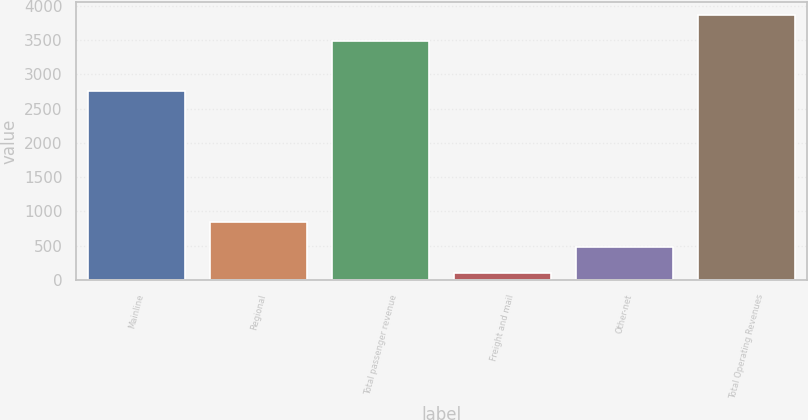Convert chart. <chart><loc_0><loc_0><loc_500><loc_500><bar_chart><fcel>Mainline<fcel>Regional<fcel>Total passenger revenue<fcel>Freight and mail<fcel>Other-net<fcel>Total Operating Revenues<nl><fcel>2763<fcel>851.2<fcel>3489<fcel>106<fcel>478.6<fcel>3861.6<nl></chart> 